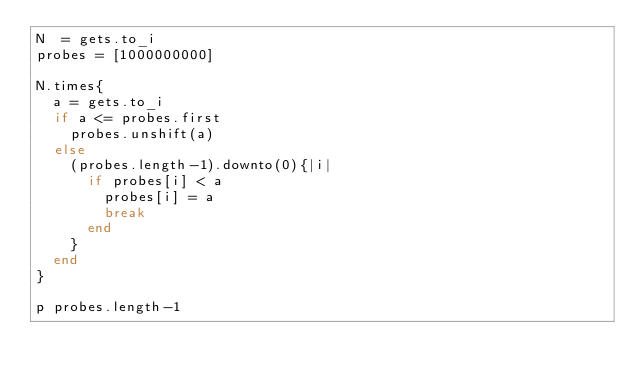Convert code to text. <code><loc_0><loc_0><loc_500><loc_500><_Ruby_>N  = gets.to_i
probes = [1000000000]

N.times{
	a = gets.to_i
	if a <= probes.first
		probes.unshift(a)
	else
		(probes.length-1).downto(0){|i|
			if probes[i] < a
				probes[i] = a
				break
			end
		}
	end
}

p probes.length-1
</code> 